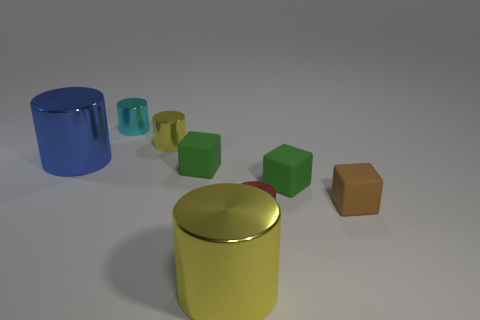Subtract 1 cylinders. How many cylinders are left? 4 Subtract all cyan cylinders. How many cylinders are left? 4 Subtract all small cyan cylinders. How many cylinders are left? 4 Subtract all gray cylinders. Subtract all blue cubes. How many cylinders are left? 5 Add 1 big green rubber cubes. How many objects exist? 9 Subtract all blocks. How many objects are left? 5 Subtract all large gray objects. Subtract all tiny brown matte things. How many objects are left? 7 Add 8 red metallic objects. How many red metallic objects are left? 9 Add 8 large brown metal cylinders. How many large brown metal cylinders exist? 8 Subtract 0 green balls. How many objects are left? 8 